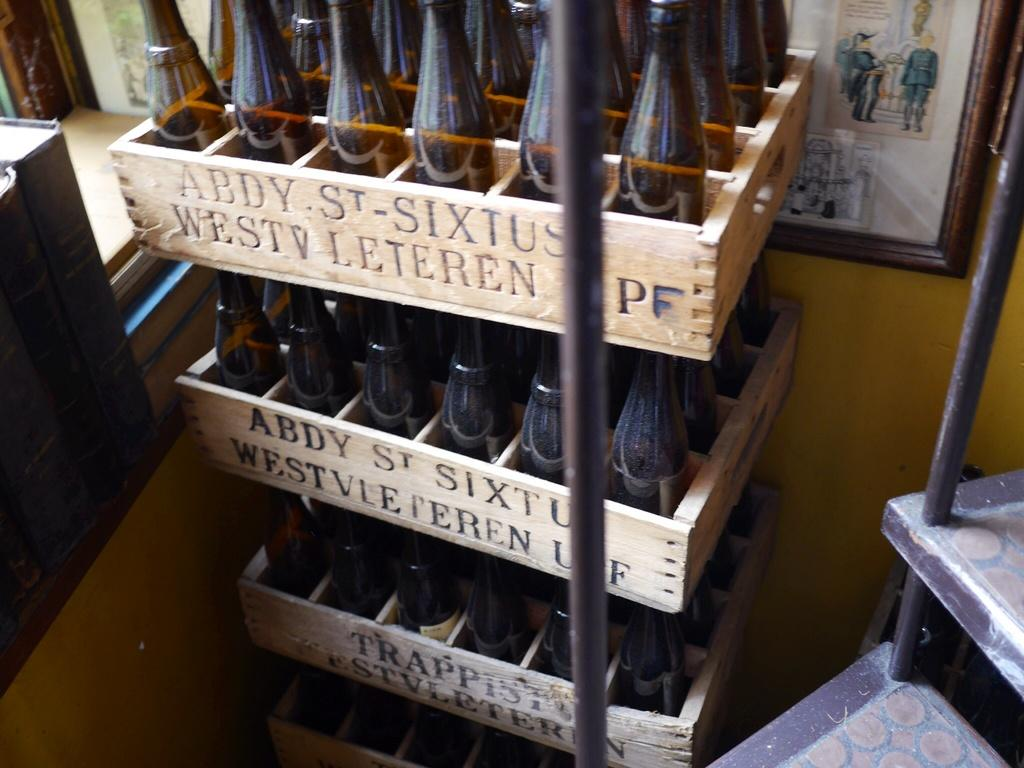<image>
Summarize the visual content of the image. The wooden beverage crates say Abdy St. Sixtus. 